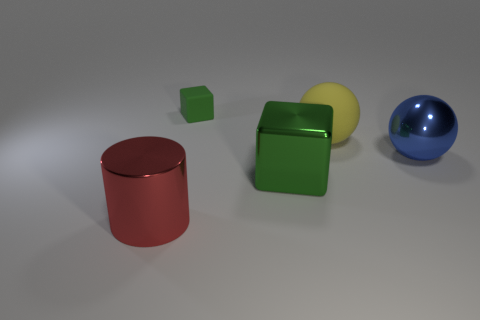Is there anything else that is the same size as the green matte block?
Offer a terse response. No. What size is the object that is made of the same material as the big yellow sphere?
Your response must be concise. Small. There is a large shiny object that is behind the green thing that is in front of the large blue ball; what is its shape?
Provide a short and direct response. Sphere. How big is the shiny thing that is to the right of the metallic cylinder and left of the big yellow sphere?
Provide a succinct answer. Large. Are there any other big matte things of the same shape as the blue thing?
Give a very brief answer. Yes. Is there any other thing that has the same shape as the red object?
Provide a succinct answer. No. What is the green block behind the big metal object to the right of the green cube that is in front of the blue metal sphere made of?
Your response must be concise. Rubber. Is there a green cube that has the same size as the yellow matte ball?
Ensure brevity in your answer.  Yes. There is a big metal thing on the left side of the cube that is on the right side of the small matte cube; what is its color?
Your answer should be very brief. Red. What number of tiny green matte things are there?
Your answer should be compact. 1. 